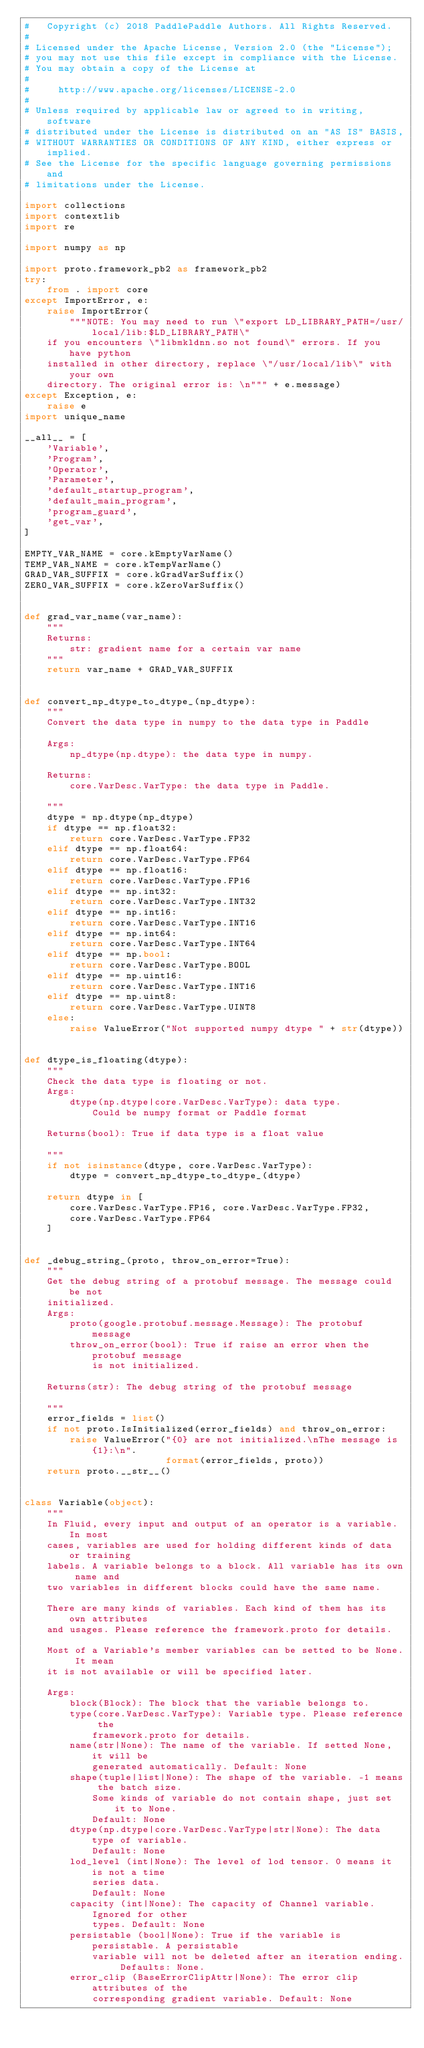<code> <loc_0><loc_0><loc_500><loc_500><_Python_>#   Copyright (c) 2018 PaddlePaddle Authors. All Rights Reserved.
#
# Licensed under the Apache License, Version 2.0 (the "License");
# you may not use this file except in compliance with the License.
# You may obtain a copy of the License at
#
#     http://www.apache.org/licenses/LICENSE-2.0
#
# Unless required by applicable law or agreed to in writing, software
# distributed under the License is distributed on an "AS IS" BASIS,
# WITHOUT WARRANTIES OR CONDITIONS OF ANY KIND, either express or implied.
# See the License for the specific language governing permissions and
# limitations under the License.

import collections
import contextlib
import re

import numpy as np

import proto.framework_pb2 as framework_pb2
try:
    from . import core
except ImportError, e:
    raise ImportError(
        """NOTE: You may need to run \"export LD_LIBRARY_PATH=/usr/local/lib:$LD_LIBRARY_PATH\"
    if you encounters \"libmkldnn.so not found\" errors. If you have python
    installed in other directory, replace \"/usr/local/lib\" with your own
    directory. The original error is: \n""" + e.message)
except Exception, e:
    raise e
import unique_name

__all__ = [
    'Variable',
    'Program',
    'Operator',
    'Parameter',
    'default_startup_program',
    'default_main_program',
    'program_guard',
    'get_var',
]

EMPTY_VAR_NAME = core.kEmptyVarName()
TEMP_VAR_NAME = core.kTempVarName()
GRAD_VAR_SUFFIX = core.kGradVarSuffix()
ZERO_VAR_SUFFIX = core.kZeroVarSuffix()


def grad_var_name(var_name):
    """
    Returns:
        str: gradient name for a certain var name
    """
    return var_name + GRAD_VAR_SUFFIX


def convert_np_dtype_to_dtype_(np_dtype):
    """
    Convert the data type in numpy to the data type in Paddle

    Args:
        np_dtype(np.dtype): the data type in numpy.

    Returns:
        core.VarDesc.VarType: the data type in Paddle.

    """
    dtype = np.dtype(np_dtype)
    if dtype == np.float32:
        return core.VarDesc.VarType.FP32
    elif dtype == np.float64:
        return core.VarDesc.VarType.FP64
    elif dtype == np.float16:
        return core.VarDesc.VarType.FP16
    elif dtype == np.int32:
        return core.VarDesc.VarType.INT32
    elif dtype == np.int16:
        return core.VarDesc.VarType.INT16
    elif dtype == np.int64:
        return core.VarDesc.VarType.INT64
    elif dtype == np.bool:
        return core.VarDesc.VarType.BOOL
    elif dtype == np.uint16:
        return core.VarDesc.VarType.INT16
    elif dtype == np.uint8:
        return core.VarDesc.VarType.UINT8
    else:
        raise ValueError("Not supported numpy dtype " + str(dtype))


def dtype_is_floating(dtype):
    """
    Check the data type is floating or not.
    Args:
        dtype(np.dtype|core.VarDesc.VarType): data type.
            Could be numpy format or Paddle format

    Returns(bool): True if data type is a float value

    """
    if not isinstance(dtype, core.VarDesc.VarType):
        dtype = convert_np_dtype_to_dtype_(dtype)

    return dtype in [
        core.VarDesc.VarType.FP16, core.VarDesc.VarType.FP32,
        core.VarDesc.VarType.FP64
    ]


def _debug_string_(proto, throw_on_error=True):
    """
    Get the debug string of a protobuf message. The message could be not
    initialized.
    Args:
        proto(google.protobuf.message.Message): The protobuf message
        throw_on_error(bool): True if raise an error when the protobuf message
            is not initialized.

    Returns(str): The debug string of the protobuf message

    """
    error_fields = list()
    if not proto.IsInitialized(error_fields) and throw_on_error:
        raise ValueError("{0} are not initialized.\nThe message is {1}:\n".
                         format(error_fields, proto))
    return proto.__str__()


class Variable(object):
    """
    In Fluid, every input and output of an operator is a variable. In most 
    cases, variables are used for holding different kinds of data or training 
    labels. A variable belongs to a block. All variable has its own name and 
    two variables in different blocks could have the same name.

    There are many kinds of variables. Each kind of them has its own attributes 
    and usages. Please reference the framework.proto for details. 

    Most of a Variable's member variables can be setted to be None. It mean 
    it is not available or will be specified later.

    Args:
        block(Block): The block that the variable belongs to.
        type(core.VarDesc.VarType): Variable type. Please reference the
            framework.proto for details.
        name(str|None): The name of the variable. If setted None, it will be
            generated automatically. Default: None
        shape(tuple|list|None): The shape of the variable. -1 means the batch size.
            Some kinds of variable do not contain shape, just set it to None.
            Default: None
        dtype(np.dtype|core.VarDesc.VarType|str|None): The data type of variable.
            Default: None
        lod_level (int|None): The level of lod tensor. 0 means it is not a time
            series data.
            Default: None
        capacity (int|None): The capacity of Channel variable. Ignored for other
            types. Default: None
        persistable (bool|None): True if the variable is persistable. A persistable
            variable will not be deleted after an iteration ending. Defaults: None.
        error_clip (BaseErrorClipAttr|None): The error clip attributes of the
            corresponding gradient variable. Default: None</code> 